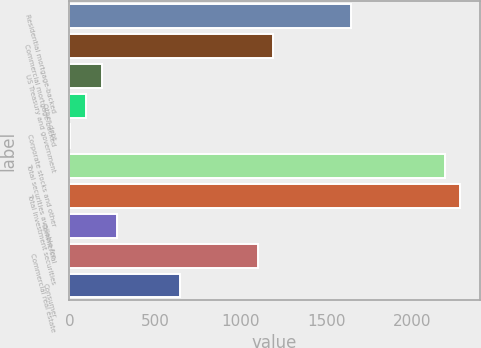<chart> <loc_0><loc_0><loc_500><loc_500><bar_chart><fcel>Residential mortgage-backed<fcel>Commercial mortgage-backed<fcel>US Treasury and government<fcel>Other debt<fcel>Corporate stocks and other<fcel>Total securities available for<fcel>Total investment securities<fcel>Commercial<fcel>Commercial real estate<fcel>Consumer<nl><fcel>1645.8<fcel>1190.3<fcel>188.2<fcel>97.1<fcel>6<fcel>2192.4<fcel>2283.5<fcel>279.3<fcel>1099.2<fcel>643.7<nl></chart> 